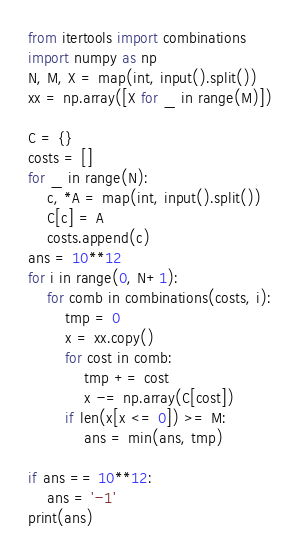Convert code to text. <code><loc_0><loc_0><loc_500><loc_500><_Python_>from itertools import combinations
import numpy as np
N, M, X = map(int, input().split())
xx = np.array([X for _ in range(M)])

C = {}
costs = []
for _ in range(N):
    c, *A = map(int, input().split())
    C[c] = A
    costs.append(c)
ans = 10**12
for i in range(0, N+1):
    for comb in combinations(costs, i):
        tmp = 0
        x = xx.copy()
        for cost in comb:
            tmp += cost
            x -= np.array(C[cost])
        if len(x[x <= 0]) >= M:
            ans = min(ans, tmp)

if ans == 10**12:
    ans = '-1'
print(ans)
</code> 